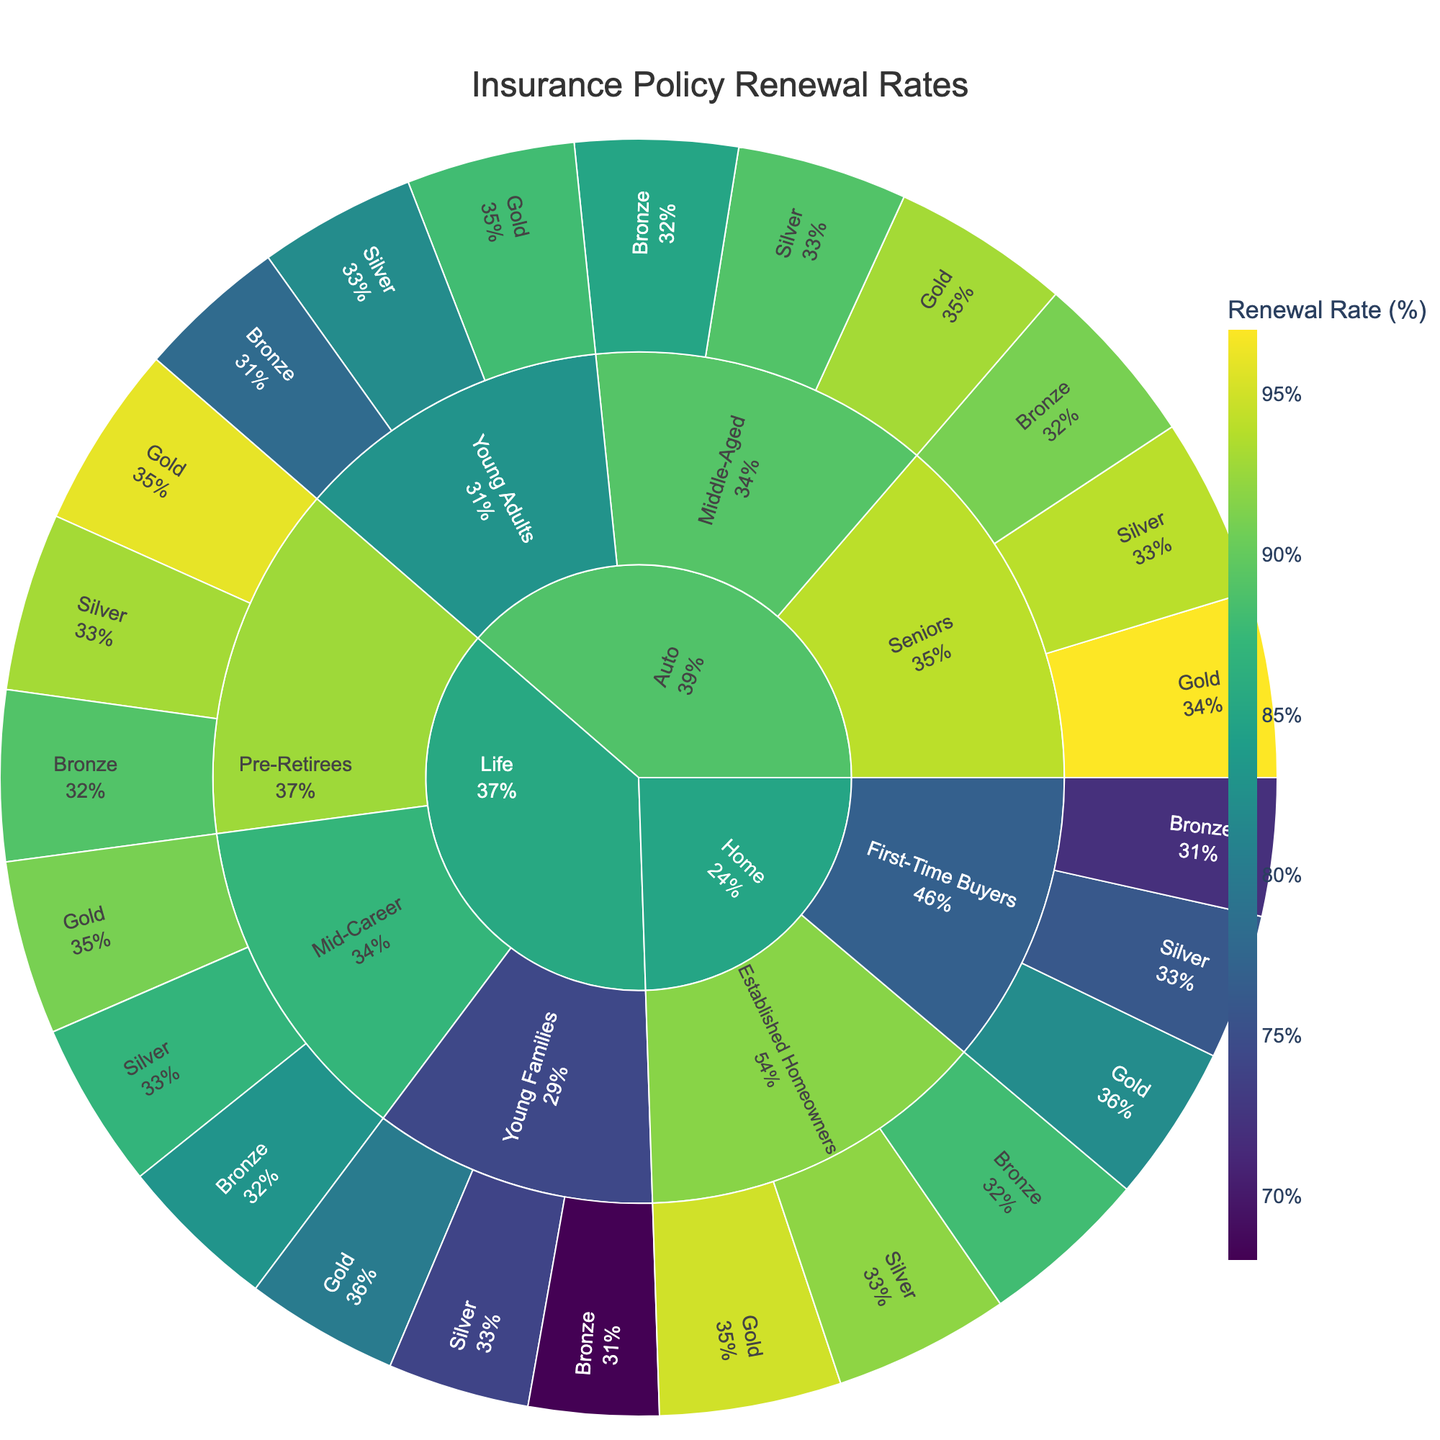What is the renewal rate for 'Gold' loyalty program among 'Seniors' with 'Auto' policies? For 'Auto' policies, navigate to the 'Auto' section, then to 'Seniors', and finally to the 'Gold' loyalty program segment. The renewal rate is shown as 97%.
Answer: 97% Which customer group has the highest renewal rate in 'Home' policies? Compare renewal rates among the different customer groups within 'Home' policies: 'First-Time Buyers' and 'Established Homeowners'. 'Established Homeowners' with the 'Gold' loyalty program has the highest renewal rate of 95%.
Answer: Established Homeowners Is the renewal rate for 'Bronze' loyalty program higher for 'Middle-Aged' customers with 'Auto' policies or 'Mid-Career' customers with 'Life' policies? Check the 'Bronze' renewal rate under 'Auto' -> 'Middle-Aged' and 'Life' -> 'Mid-Career'. The renewal rate for 'Auto' -> 'Middle-Aged' is 85%, and for 'Life' -> 'Mid-Career' is 83%. Compare these values.
Answer: Middle-Aged with Auto policies Which loyalty program has the lowest average renewal rate for 'Life' policies? Calculate the average renewal rate for each loyalty program ('Bronze', 'Silver', 'Gold') within 'Life' policies. The average renewal rates are (68+83+89)/3=80 for 'Bronze', (74+87+93)/3=84.67 for 'Silver', and (80+91+96)/3=89 for 'Gold'. The 'Bronze' program has the lowest average renewal rate.
Answer: Bronze Across all policy types, which customer group and loyalty program combination has the highest renewal rate? Review all customer group and loyalty program combinations within each policy type to find the highest renewal rate. The 'Gold' program for 'Seniors' under 'Auto' has the highest renewal rate of 97%.
Answer: Seniors with Gold under Auto What is the difference in renewal rates between 'Gold' and 'Bronze' loyalty programs for 'Young Families' with 'Life' policies? For 'Life' policies under 'Young Families', find the renewal rates: 'Gold' is 80%, and 'Bronze' is 68%. Compute the difference: 80 - 68 = 12.
Answer: 12 How do the renewal rates for 'Established Homeowners' compare between 'Bronze' and 'Silver' loyalty programs? Navigate to 'Home' -> 'Established Homeowners'. The renewal rate is 88% for 'Bronze' and 92% for 'Silver'. Compare these values directly.
Answer: Silver is higher What is the average renewal rate for the 'Silver' loyalty program across all customer groups for 'Auto' policies? For 'Auto' policies, find the renewal rates for 'Silver' in each customer group: 'Young Adults' (82), 'Middle-Aged' (89), and 'Seniors' (94). Average these: (82+89+94)/3 = 88.33.
Answer: 88.33 Which policy type has the most consistent renewal rates across all loyalty programs? Evaluate the variability within each policy type by comparing the renewal rates for 'Bronze', 'Silver', and 'Gold' programs. 'Auto' policies have consistent high renewal rates from 78% to 97%, unlike other policy types with broader ranges.
Answer: Auto 